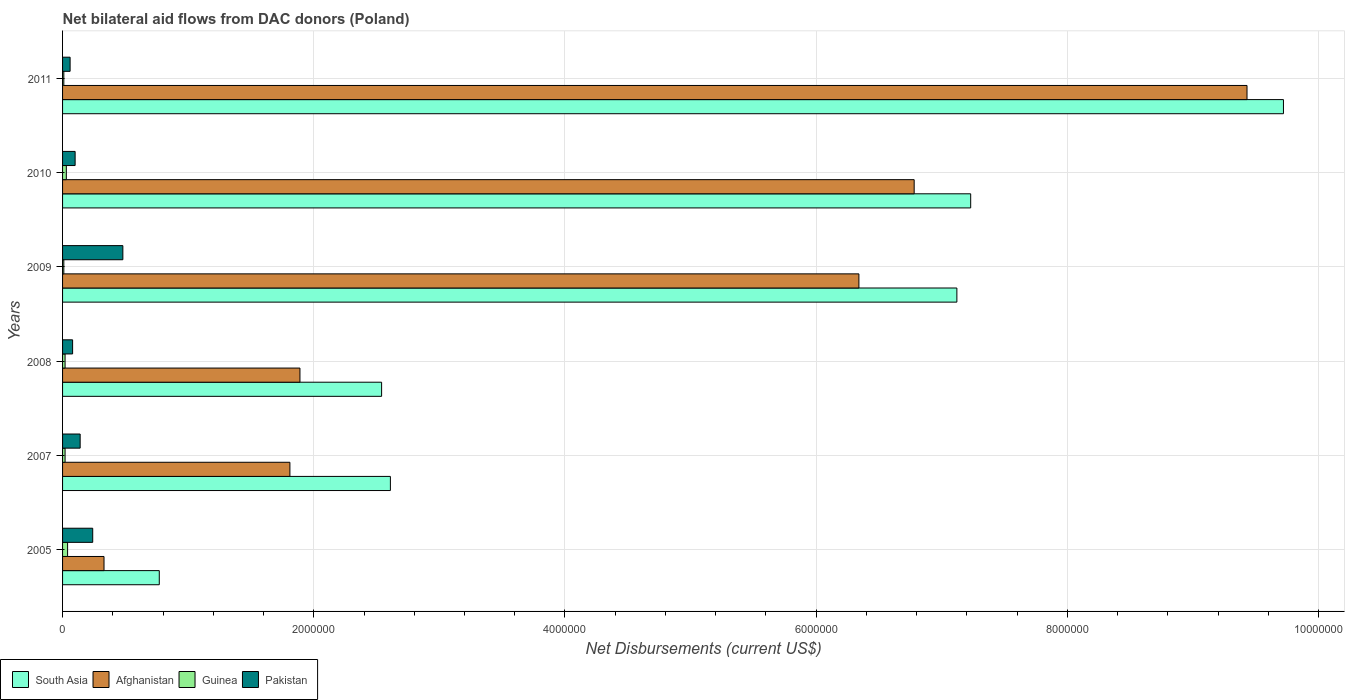How many groups of bars are there?
Provide a succinct answer. 6. Are the number of bars per tick equal to the number of legend labels?
Give a very brief answer. Yes. How many bars are there on the 2nd tick from the top?
Your response must be concise. 4. How many bars are there on the 5th tick from the bottom?
Your answer should be compact. 4. In how many cases, is the number of bars for a given year not equal to the number of legend labels?
Offer a terse response. 0. What is the net bilateral aid flows in South Asia in 2005?
Give a very brief answer. 7.70e+05. Across all years, what is the maximum net bilateral aid flows in South Asia?
Offer a very short reply. 9.72e+06. Across all years, what is the minimum net bilateral aid flows in Pakistan?
Offer a very short reply. 6.00e+04. In which year was the net bilateral aid flows in South Asia minimum?
Offer a very short reply. 2005. What is the difference between the net bilateral aid flows in South Asia in 2009 and that in 2011?
Your answer should be very brief. -2.60e+06. What is the difference between the net bilateral aid flows in South Asia in 2009 and the net bilateral aid flows in Guinea in 2011?
Make the answer very short. 7.11e+06. What is the average net bilateral aid flows in Pakistan per year?
Provide a short and direct response. 1.83e+05. In the year 2010, what is the difference between the net bilateral aid flows in South Asia and net bilateral aid flows in Afghanistan?
Offer a terse response. 4.50e+05. What is the difference between the highest and the second highest net bilateral aid flows in South Asia?
Your answer should be compact. 2.49e+06. What is the difference between the highest and the lowest net bilateral aid flows in Pakistan?
Your response must be concise. 4.20e+05. Is the sum of the net bilateral aid flows in Afghanistan in 2005 and 2009 greater than the maximum net bilateral aid flows in Guinea across all years?
Offer a terse response. Yes. Is it the case that in every year, the sum of the net bilateral aid flows in Afghanistan and net bilateral aid flows in Pakistan is greater than the sum of net bilateral aid flows in Guinea and net bilateral aid flows in South Asia?
Your answer should be compact. No. What does the 2nd bar from the top in 2009 represents?
Make the answer very short. Guinea. Does the graph contain grids?
Ensure brevity in your answer.  Yes. Where does the legend appear in the graph?
Make the answer very short. Bottom left. What is the title of the graph?
Offer a terse response. Net bilateral aid flows from DAC donors (Poland). Does "Belize" appear as one of the legend labels in the graph?
Ensure brevity in your answer.  No. What is the label or title of the X-axis?
Your response must be concise. Net Disbursements (current US$). What is the label or title of the Y-axis?
Provide a short and direct response. Years. What is the Net Disbursements (current US$) of South Asia in 2005?
Keep it short and to the point. 7.70e+05. What is the Net Disbursements (current US$) of South Asia in 2007?
Your response must be concise. 2.61e+06. What is the Net Disbursements (current US$) in Afghanistan in 2007?
Keep it short and to the point. 1.81e+06. What is the Net Disbursements (current US$) in Guinea in 2007?
Provide a short and direct response. 2.00e+04. What is the Net Disbursements (current US$) in South Asia in 2008?
Provide a short and direct response. 2.54e+06. What is the Net Disbursements (current US$) in Afghanistan in 2008?
Keep it short and to the point. 1.89e+06. What is the Net Disbursements (current US$) of Guinea in 2008?
Provide a short and direct response. 2.00e+04. What is the Net Disbursements (current US$) in Pakistan in 2008?
Provide a short and direct response. 8.00e+04. What is the Net Disbursements (current US$) of South Asia in 2009?
Keep it short and to the point. 7.12e+06. What is the Net Disbursements (current US$) of Afghanistan in 2009?
Offer a terse response. 6.34e+06. What is the Net Disbursements (current US$) in South Asia in 2010?
Ensure brevity in your answer.  7.23e+06. What is the Net Disbursements (current US$) in Afghanistan in 2010?
Your answer should be very brief. 6.78e+06. What is the Net Disbursements (current US$) in Guinea in 2010?
Offer a very short reply. 3.00e+04. What is the Net Disbursements (current US$) in Pakistan in 2010?
Provide a short and direct response. 1.00e+05. What is the Net Disbursements (current US$) of South Asia in 2011?
Your answer should be very brief. 9.72e+06. What is the Net Disbursements (current US$) in Afghanistan in 2011?
Provide a succinct answer. 9.43e+06. What is the Net Disbursements (current US$) in Guinea in 2011?
Give a very brief answer. 10000. What is the Net Disbursements (current US$) of Pakistan in 2011?
Make the answer very short. 6.00e+04. Across all years, what is the maximum Net Disbursements (current US$) of South Asia?
Provide a short and direct response. 9.72e+06. Across all years, what is the maximum Net Disbursements (current US$) of Afghanistan?
Keep it short and to the point. 9.43e+06. Across all years, what is the maximum Net Disbursements (current US$) in Guinea?
Offer a terse response. 4.00e+04. Across all years, what is the minimum Net Disbursements (current US$) of South Asia?
Offer a terse response. 7.70e+05. Across all years, what is the minimum Net Disbursements (current US$) of Guinea?
Your response must be concise. 10000. Across all years, what is the minimum Net Disbursements (current US$) of Pakistan?
Provide a succinct answer. 6.00e+04. What is the total Net Disbursements (current US$) of South Asia in the graph?
Offer a terse response. 3.00e+07. What is the total Net Disbursements (current US$) in Afghanistan in the graph?
Offer a terse response. 2.66e+07. What is the total Net Disbursements (current US$) of Pakistan in the graph?
Offer a terse response. 1.10e+06. What is the difference between the Net Disbursements (current US$) of South Asia in 2005 and that in 2007?
Provide a short and direct response. -1.84e+06. What is the difference between the Net Disbursements (current US$) of Afghanistan in 2005 and that in 2007?
Your answer should be compact. -1.48e+06. What is the difference between the Net Disbursements (current US$) of Guinea in 2005 and that in 2007?
Offer a very short reply. 2.00e+04. What is the difference between the Net Disbursements (current US$) of Pakistan in 2005 and that in 2007?
Give a very brief answer. 1.00e+05. What is the difference between the Net Disbursements (current US$) of South Asia in 2005 and that in 2008?
Provide a short and direct response. -1.77e+06. What is the difference between the Net Disbursements (current US$) in Afghanistan in 2005 and that in 2008?
Ensure brevity in your answer.  -1.56e+06. What is the difference between the Net Disbursements (current US$) in South Asia in 2005 and that in 2009?
Your answer should be very brief. -6.35e+06. What is the difference between the Net Disbursements (current US$) of Afghanistan in 2005 and that in 2009?
Give a very brief answer. -6.01e+06. What is the difference between the Net Disbursements (current US$) in Pakistan in 2005 and that in 2009?
Your answer should be compact. -2.40e+05. What is the difference between the Net Disbursements (current US$) in South Asia in 2005 and that in 2010?
Make the answer very short. -6.46e+06. What is the difference between the Net Disbursements (current US$) of Afghanistan in 2005 and that in 2010?
Offer a terse response. -6.45e+06. What is the difference between the Net Disbursements (current US$) in Guinea in 2005 and that in 2010?
Your answer should be compact. 10000. What is the difference between the Net Disbursements (current US$) of South Asia in 2005 and that in 2011?
Your answer should be very brief. -8.95e+06. What is the difference between the Net Disbursements (current US$) in Afghanistan in 2005 and that in 2011?
Give a very brief answer. -9.10e+06. What is the difference between the Net Disbursements (current US$) of Guinea in 2005 and that in 2011?
Make the answer very short. 3.00e+04. What is the difference between the Net Disbursements (current US$) in Pakistan in 2005 and that in 2011?
Keep it short and to the point. 1.80e+05. What is the difference between the Net Disbursements (current US$) of South Asia in 2007 and that in 2008?
Provide a succinct answer. 7.00e+04. What is the difference between the Net Disbursements (current US$) of Pakistan in 2007 and that in 2008?
Offer a very short reply. 6.00e+04. What is the difference between the Net Disbursements (current US$) of South Asia in 2007 and that in 2009?
Provide a succinct answer. -4.51e+06. What is the difference between the Net Disbursements (current US$) in Afghanistan in 2007 and that in 2009?
Your answer should be very brief. -4.53e+06. What is the difference between the Net Disbursements (current US$) of Guinea in 2007 and that in 2009?
Your answer should be very brief. 10000. What is the difference between the Net Disbursements (current US$) of South Asia in 2007 and that in 2010?
Provide a succinct answer. -4.62e+06. What is the difference between the Net Disbursements (current US$) of Afghanistan in 2007 and that in 2010?
Make the answer very short. -4.97e+06. What is the difference between the Net Disbursements (current US$) of Pakistan in 2007 and that in 2010?
Ensure brevity in your answer.  4.00e+04. What is the difference between the Net Disbursements (current US$) of South Asia in 2007 and that in 2011?
Ensure brevity in your answer.  -7.11e+06. What is the difference between the Net Disbursements (current US$) in Afghanistan in 2007 and that in 2011?
Keep it short and to the point. -7.62e+06. What is the difference between the Net Disbursements (current US$) of Guinea in 2007 and that in 2011?
Provide a succinct answer. 10000. What is the difference between the Net Disbursements (current US$) in Pakistan in 2007 and that in 2011?
Your answer should be compact. 8.00e+04. What is the difference between the Net Disbursements (current US$) of South Asia in 2008 and that in 2009?
Give a very brief answer. -4.58e+06. What is the difference between the Net Disbursements (current US$) in Afghanistan in 2008 and that in 2009?
Provide a succinct answer. -4.45e+06. What is the difference between the Net Disbursements (current US$) of Guinea in 2008 and that in 2009?
Provide a short and direct response. 10000. What is the difference between the Net Disbursements (current US$) of Pakistan in 2008 and that in 2009?
Your answer should be compact. -4.00e+05. What is the difference between the Net Disbursements (current US$) in South Asia in 2008 and that in 2010?
Ensure brevity in your answer.  -4.69e+06. What is the difference between the Net Disbursements (current US$) of Afghanistan in 2008 and that in 2010?
Make the answer very short. -4.89e+06. What is the difference between the Net Disbursements (current US$) in Guinea in 2008 and that in 2010?
Give a very brief answer. -10000. What is the difference between the Net Disbursements (current US$) of Pakistan in 2008 and that in 2010?
Offer a very short reply. -2.00e+04. What is the difference between the Net Disbursements (current US$) in South Asia in 2008 and that in 2011?
Make the answer very short. -7.18e+06. What is the difference between the Net Disbursements (current US$) of Afghanistan in 2008 and that in 2011?
Offer a terse response. -7.54e+06. What is the difference between the Net Disbursements (current US$) in Guinea in 2008 and that in 2011?
Your response must be concise. 10000. What is the difference between the Net Disbursements (current US$) of South Asia in 2009 and that in 2010?
Your response must be concise. -1.10e+05. What is the difference between the Net Disbursements (current US$) of Afghanistan in 2009 and that in 2010?
Ensure brevity in your answer.  -4.40e+05. What is the difference between the Net Disbursements (current US$) in Guinea in 2009 and that in 2010?
Provide a succinct answer. -2.00e+04. What is the difference between the Net Disbursements (current US$) in South Asia in 2009 and that in 2011?
Offer a terse response. -2.60e+06. What is the difference between the Net Disbursements (current US$) in Afghanistan in 2009 and that in 2011?
Offer a terse response. -3.09e+06. What is the difference between the Net Disbursements (current US$) in Pakistan in 2009 and that in 2011?
Your answer should be compact. 4.20e+05. What is the difference between the Net Disbursements (current US$) in South Asia in 2010 and that in 2011?
Provide a succinct answer. -2.49e+06. What is the difference between the Net Disbursements (current US$) in Afghanistan in 2010 and that in 2011?
Make the answer very short. -2.65e+06. What is the difference between the Net Disbursements (current US$) in Guinea in 2010 and that in 2011?
Give a very brief answer. 2.00e+04. What is the difference between the Net Disbursements (current US$) in South Asia in 2005 and the Net Disbursements (current US$) in Afghanistan in 2007?
Keep it short and to the point. -1.04e+06. What is the difference between the Net Disbursements (current US$) of South Asia in 2005 and the Net Disbursements (current US$) of Guinea in 2007?
Offer a terse response. 7.50e+05. What is the difference between the Net Disbursements (current US$) in South Asia in 2005 and the Net Disbursements (current US$) in Pakistan in 2007?
Your response must be concise. 6.30e+05. What is the difference between the Net Disbursements (current US$) in Guinea in 2005 and the Net Disbursements (current US$) in Pakistan in 2007?
Offer a terse response. -1.00e+05. What is the difference between the Net Disbursements (current US$) in South Asia in 2005 and the Net Disbursements (current US$) in Afghanistan in 2008?
Your answer should be very brief. -1.12e+06. What is the difference between the Net Disbursements (current US$) of South Asia in 2005 and the Net Disbursements (current US$) of Guinea in 2008?
Your answer should be compact. 7.50e+05. What is the difference between the Net Disbursements (current US$) in South Asia in 2005 and the Net Disbursements (current US$) in Pakistan in 2008?
Ensure brevity in your answer.  6.90e+05. What is the difference between the Net Disbursements (current US$) in Afghanistan in 2005 and the Net Disbursements (current US$) in Pakistan in 2008?
Your answer should be compact. 2.50e+05. What is the difference between the Net Disbursements (current US$) of Guinea in 2005 and the Net Disbursements (current US$) of Pakistan in 2008?
Keep it short and to the point. -4.00e+04. What is the difference between the Net Disbursements (current US$) of South Asia in 2005 and the Net Disbursements (current US$) of Afghanistan in 2009?
Your response must be concise. -5.57e+06. What is the difference between the Net Disbursements (current US$) of South Asia in 2005 and the Net Disbursements (current US$) of Guinea in 2009?
Keep it short and to the point. 7.60e+05. What is the difference between the Net Disbursements (current US$) in South Asia in 2005 and the Net Disbursements (current US$) in Pakistan in 2009?
Give a very brief answer. 2.90e+05. What is the difference between the Net Disbursements (current US$) in Afghanistan in 2005 and the Net Disbursements (current US$) in Guinea in 2009?
Provide a short and direct response. 3.20e+05. What is the difference between the Net Disbursements (current US$) of Afghanistan in 2005 and the Net Disbursements (current US$) of Pakistan in 2009?
Provide a short and direct response. -1.50e+05. What is the difference between the Net Disbursements (current US$) of Guinea in 2005 and the Net Disbursements (current US$) of Pakistan in 2009?
Ensure brevity in your answer.  -4.40e+05. What is the difference between the Net Disbursements (current US$) of South Asia in 2005 and the Net Disbursements (current US$) of Afghanistan in 2010?
Your response must be concise. -6.01e+06. What is the difference between the Net Disbursements (current US$) of South Asia in 2005 and the Net Disbursements (current US$) of Guinea in 2010?
Offer a very short reply. 7.40e+05. What is the difference between the Net Disbursements (current US$) in South Asia in 2005 and the Net Disbursements (current US$) in Pakistan in 2010?
Provide a succinct answer. 6.70e+05. What is the difference between the Net Disbursements (current US$) of Afghanistan in 2005 and the Net Disbursements (current US$) of Guinea in 2010?
Provide a succinct answer. 3.00e+05. What is the difference between the Net Disbursements (current US$) in Afghanistan in 2005 and the Net Disbursements (current US$) in Pakistan in 2010?
Provide a short and direct response. 2.30e+05. What is the difference between the Net Disbursements (current US$) of Guinea in 2005 and the Net Disbursements (current US$) of Pakistan in 2010?
Provide a short and direct response. -6.00e+04. What is the difference between the Net Disbursements (current US$) in South Asia in 2005 and the Net Disbursements (current US$) in Afghanistan in 2011?
Offer a very short reply. -8.66e+06. What is the difference between the Net Disbursements (current US$) in South Asia in 2005 and the Net Disbursements (current US$) in Guinea in 2011?
Keep it short and to the point. 7.60e+05. What is the difference between the Net Disbursements (current US$) in South Asia in 2005 and the Net Disbursements (current US$) in Pakistan in 2011?
Make the answer very short. 7.10e+05. What is the difference between the Net Disbursements (current US$) in Afghanistan in 2005 and the Net Disbursements (current US$) in Pakistan in 2011?
Your answer should be compact. 2.70e+05. What is the difference between the Net Disbursements (current US$) of South Asia in 2007 and the Net Disbursements (current US$) of Afghanistan in 2008?
Ensure brevity in your answer.  7.20e+05. What is the difference between the Net Disbursements (current US$) in South Asia in 2007 and the Net Disbursements (current US$) in Guinea in 2008?
Your answer should be compact. 2.59e+06. What is the difference between the Net Disbursements (current US$) of South Asia in 2007 and the Net Disbursements (current US$) of Pakistan in 2008?
Give a very brief answer. 2.53e+06. What is the difference between the Net Disbursements (current US$) of Afghanistan in 2007 and the Net Disbursements (current US$) of Guinea in 2008?
Your response must be concise. 1.79e+06. What is the difference between the Net Disbursements (current US$) in Afghanistan in 2007 and the Net Disbursements (current US$) in Pakistan in 2008?
Make the answer very short. 1.73e+06. What is the difference between the Net Disbursements (current US$) of South Asia in 2007 and the Net Disbursements (current US$) of Afghanistan in 2009?
Keep it short and to the point. -3.73e+06. What is the difference between the Net Disbursements (current US$) of South Asia in 2007 and the Net Disbursements (current US$) of Guinea in 2009?
Offer a very short reply. 2.60e+06. What is the difference between the Net Disbursements (current US$) in South Asia in 2007 and the Net Disbursements (current US$) in Pakistan in 2009?
Give a very brief answer. 2.13e+06. What is the difference between the Net Disbursements (current US$) in Afghanistan in 2007 and the Net Disbursements (current US$) in Guinea in 2009?
Your response must be concise. 1.80e+06. What is the difference between the Net Disbursements (current US$) in Afghanistan in 2007 and the Net Disbursements (current US$) in Pakistan in 2009?
Provide a short and direct response. 1.33e+06. What is the difference between the Net Disbursements (current US$) of Guinea in 2007 and the Net Disbursements (current US$) of Pakistan in 2009?
Offer a terse response. -4.60e+05. What is the difference between the Net Disbursements (current US$) in South Asia in 2007 and the Net Disbursements (current US$) in Afghanistan in 2010?
Your answer should be compact. -4.17e+06. What is the difference between the Net Disbursements (current US$) of South Asia in 2007 and the Net Disbursements (current US$) of Guinea in 2010?
Make the answer very short. 2.58e+06. What is the difference between the Net Disbursements (current US$) in South Asia in 2007 and the Net Disbursements (current US$) in Pakistan in 2010?
Give a very brief answer. 2.51e+06. What is the difference between the Net Disbursements (current US$) of Afghanistan in 2007 and the Net Disbursements (current US$) of Guinea in 2010?
Offer a very short reply. 1.78e+06. What is the difference between the Net Disbursements (current US$) in Afghanistan in 2007 and the Net Disbursements (current US$) in Pakistan in 2010?
Give a very brief answer. 1.71e+06. What is the difference between the Net Disbursements (current US$) in South Asia in 2007 and the Net Disbursements (current US$) in Afghanistan in 2011?
Your response must be concise. -6.82e+06. What is the difference between the Net Disbursements (current US$) in South Asia in 2007 and the Net Disbursements (current US$) in Guinea in 2011?
Ensure brevity in your answer.  2.60e+06. What is the difference between the Net Disbursements (current US$) in South Asia in 2007 and the Net Disbursements (current US$) in Pakistan in 2011?
Your answer should be compact. 2.55e+06. What is the difference between the Net Disbursements (current US$) in Afghanistan in 2007 and the Net Disbursements (current US$) in Guinea in 2011?
Offer a very short reply. 1.80e+06. What is the difference between the Net Disbursements (current US$) of Afghanistan in 2007 and the Net Disbursements (current US$) of Pakistan in 2011?
Offer a very short reply. 1.75e+06. What is the difference between the Net Disbursements (current US$) in Guinea in 2007 and the Net Disbursements (current US$) in Pakistan in 2011?
Offer a terse response. -4.00e+04. What is the difference between the Net Disbursements (current US$) of South Asia in 2008 and the Net Disbursements (current US$) of Afghanistan in 2009?
Make the answer very short. -3.80e+06. What is the difference between the Net Disbursements (current US$) in South Asia in 2008 and the Net Disbursements (current US$) in Guinea in 2009?
Provide a short and direct response. 2.53e+06. What is the difference between the Net Disbursements (current US$) of South Asia in 2008 and the Net Disbursements (current US$) of Pakistan in 2009?
Keep it short and to the point. 2.06e+06. What is the difference between the Net Disbursements (current US$) of Afghanistan in 2008 and the Net Disbursements (current US$) of Guinea in 2009?
Offer a terse response. 1.88e+06. What is the difference between the Net Disbursements (current US$) of Afghanistan in 2008 and the Net Disbursements (current US$) of Pakistan in 2009?
Your answer should be compact. 1.41e+06. What is the difference between the Net Disbursements (current US$) in Guinea in 2008 and the Net Disbursements (current US$) in Pakistan in 2009?
Your response must be concise. -4.60e+05. What is the difference between the Net Disbursements (current US$) in South Asia in 2008 and the Net Disbursements (current US$) in Afghanistan in 2010?
Offer a very short reply. -4.24e+06. What is the difference between the Net Disbursements (current US$) in South Asia in 2008 and the Net Disbursements (current US$) in Guinea in 2010?
Provide a short and direct response. 2.51e+06. What is the difference between the Net Disbursements (current US$) in South Asia in 2008 and the Net Disbursements (current US$) in Pakistan in 2010?
Keep it short and to the point. 2.44e+06. What is the difference between the Net Disbursements (current US$) of Afghanistan in 2008 and the Net Disbursements (current US$) of Guinea in 2010?
Your answer should be very brief. 1.86e+06. What is the difference between the Net Disbursements (current US$) of Afghanistan in 2008 and the Net Disbursements (current US$) of Pakistan in 2010?
Your response must be concise. 1.79e+06. What is the difference between the Net Disbursements (current US$) of South Asia in 2008 and the Net Disbursements (current US$) of Afghanistan in 2011?
Keep it short and to the point. -6.89e+06. What is the difference between the Net Disbursements (current US$) in South Asia in 2008 and the Net Disbursements (current US$) in Guinea in 2011?
Your answer should be very brief. 2.53e+06. What is the difference between the Net Disbursements (current US$) in South Asia in 2008 and the Net Disbursements (current US$) in Pakistan in 2011?
Keep it short and to the point. 2.48e+06. What is the difference between the Net Disbursements (current US$) of Afghanistan in 2008 and the Net Disbursements (current US$) of Guinea in 2011?
Your response must be concise. 1.88e+06. What is the difference between the Net Disbursements (current US$) of Afghanistan in 2008 and the Net Disbursements (current US$) of Pakistan in 2011?
Ensure brevity in your answer.  1.83e+06. What is the difference between the Net Disbursements (current US$) in South Asia in 2009 and the Net Disbursements (current US$) in Afghanistan in 2010?
Make the answer very short. 3.40e+05. What is the difference between the Net Disbursements (current US$) in South Asia in 2009 and the Net Disbursements (current US$) in Guinea in 2010?
Offer a terse response. 7.09e+06. What is the difference between the Net Disbursements (current US$) in South Asia in 2009 and the Net Disbursements (current US$) in Pakistan in 2010?
Ensure brevity in your answer.  7.02e+06. What is the difference between the Net Disbursements (current US$) in Afghanistan in 2009 and the Net Disbursements (current US$) in Guinea in 2010?
Make the answer very short. 6.31e+06. What is the difference between the Net Disbursements (current US$) of Afghanistan in 2009 and the Net Disbursements (current US$) of Pakistan in 2010?
Your response must be concise. 6.24e+06. What is the difference between the Net Disbursements (current US$) of South Asia in 2009 and the Net Disbursements (current US$) of Afghanistan in 2011?
Provide a succinct answer. -2.31e+06. What is the difference between the Net Disbursements (current US$) in South Asia in 2009 and the Net Disbursements (current US$) in Guinea in 2011?
Provide a succinct answer. 7.11e+06. What is the difference between the Net Disbursements (current US$) of South Asia in 2009 and the Net Disbursements (current US$) of Pakistan in 2011?
Your answer should be compact. 7.06e+06. What is the difference between the Net Disbursements (current US$) of Afghanistan in 2009 and the Net Disbursements (current US$) of Guinea in 2011?
Your answer should be very brief. 6.33e+06. What is the difference between the Net Disbursements (current US$) in Afghanistan in 2009 and the Net Disbursements (current US$) in Pakistan in 2011?
Keep it short and to the point. 6.28e+06. What is the difference between the Net Disbursements (current US$) of Guinea in 2009 and the Net Disbursements (current US$) of Pakistan in 2011?
Give a very brief answer. -5.00e+04. What is the difference between the Net Disbursements (current US$) in South Asia in 2010 and the Net Disbursements (current US$) in Afghanistan in 2011?
Your answer should be very brief. -2.20e+06. What is the difference between the Net Disbursements (current US$) in South Asia in 2010 and the Net Disbursements (current US$) in Guinea in 2011?
Ensure brevity in your answer.  7.22e+06. What is the difference between the Net Disbursements (current US$) in South Asia in 2010 and the Net Disbursements (current US$) in Pakistan in 2011?
Make the answer very short. 7.17e+06. What is the difference between the Net Disbursements (current US$) in Afghanistan in 2010 and the Net Disbursements (current US$) in Guinea in 2011?
Provide a succinct answer. 6.77e+06. What is the difference between the Net Disbursements (current US$) of Afghanistan in 2010 and the Net Disbursements (current US$) of Pakistan in 2011?
Provide a short and direct response. 6.72e+06. What is the difference between the Net Disbursements (current US$) in Guinea in 2010 and the Net Disbursements (current US$) in Pakistan in 2011?
Ensure brevity in your answer.  -3.00e+04. What is the average Net Disbursements (current US$) in South Asia per year?
Your answer should be compact. 5.00e+06. What is the average Net Disbursements (current US$) in Afghanistan per year?
Your answer should be compact. 4.43e+06. What is the average Net Disbursements (current US$) of Guinea per year?
Offer a very short reply. 2.17e+04. What is the average Net Disbursements (current US$) in Pakistan per year?
Offer a terse response. 1.83e+05. In the year 2005, what is the difference between the Net Disbursements (current US$) in South Asia and Net Disbursements (current US$) in Afghanistan?
Give a very brief answer. 4.40e+05. In the year 2005, what is the difference between the Net Disbursements (current US$) of South Asia and Net Disbursements (current US$) of Guinea?
Your answer should be very brief. 7.30e+05. In the year 2005, what is the difference between the Net Disbursements (current US$) of South Asia and Net Disbursements (current US$) of Pakistan?
Keep it short and to the point. 5.30e+05. In the year 2005, what is the difference between the Net Disbursements (current US$) of Guinea and Net Disbursements (current US$) of Pakistan?
Provide a succinct answer. -2.00e+05. In the year 2007, what is the difference between the Net Disbursements (current US$) in South Asia and Net Disbursements (current US$) in Afghanistan?
Make the answer very short. 8.00e+05. In the year 2007, what is the difference between the Net Disbursements (current US$) of South Asia and Net Disbursements (current US$) of Guinea?
Offer a very short reply. 2.59e+06. In the year 2007, what is the difference between the Net Disbursements (current US$) in South Asia and Net Disbursements (current US$) in Pakistan?
Offer a very short reply. 2.47e+06. In the year 2007, what is the difference between the Net Disbursements (current US$) of Afghanistan and Net Disbursements (current US$) of Guinea?
Offer a terse response. 1.79e+06. In the year 2007, what is the difference between the Net Disbursements (current US$) in Afghanistan and Net Disbursements (current US$) in Pakistan?
Make the answer very short. 1.67e+06. In the year 2007, what is the difference between the Net Disbursements (current US$) of Guinea and Net Disbursements (current US$) of Pakistan?
Keep it short and to the point. -1.20e+05. In the year 2008, what is the difference between the Net Disbursements (current US$) in South Asia and Net Disbursements (current US$) in Afghanistan?
Offer a very short reply. 6.50e+05. In the year 2008, what is the difference between the Net Disbursements (current US$) of South Asia and Net Disbursements (current US$) of Guinea?
Provide a short and direct response. 2.52e+06. In the year 2008, what is the difference between the Net Disbursements (current US$) of South Asia and Net Disbursements (current US$) of Pakistan?
Ensure brevity in your answer.  2.46e+06. In the year 2008, what is the difference between the Net Disbursements (current US$) in Afghanistan and Net Disbursements (current US$) in Guinea?
Ensure brevity in your answer.  1.87e+06. In the year 2008, what is the difference between the Net Disbursements (current US$) of Afghanistan and Net Disbursements (current US$) of Pakistan?
Keep it short and to the point. 1.81e+06. In the year 2009, what is the difference between the Net Disbursements (current US$) in South Asia and Net Disbursements (current US$) in Afghanistan?
Your answer should be very brief. 7.80e+05. In the year 2009, what is the difference between the Net Disbursements (current US$) in South Asia and Net Disbursements (current US$) in Guinea?
Offer a terse response. 7.11e+06. In the year 2009, what is the difference between the Net Disbursements (current US$) of South Asia and Net Disbursements (current US$) of Pakistan?
Your answer should be very brief. 6.64e+06. In the year 2009, what is the difference between the Net Disbursements (current US$) of Afghanistan and Net Disbursements (current US$) of Guinea?
Your response must be concise. 6.33e+06. In the year 2009, what is the difference between the Net Disbursements (current US$) in Afghanistan and Net Disbursements (current US$) in Pakistan?
Give a very brief answer. 5.86e+06. In the year 2009, what is the difference between the Net Disbursements (current US$) in Guinea and Net Disbursements (current US$) in Pakistan?
Ensure brevity in your answer.  -4.70e+05. In the year 2010, what is the difference between the Net Disbursements (current US$) of South Asia and Net Disbursements (current US$) of Guinea?
Keep it short and to the point. 7.20e+06. In the year 2010, what is the difference between the Net Disbursements (current US$) of South Asia and Net Disbursements (current US$) of Pakistan?
Keep it short and to the point. 7.13e+06. In the year 2010, what is the difference between the Net Disbursements (current US$) in Afghanistan and Net Disbursements (current US$) in Guinea?
Your response must be concise. 6.75e+06. In the year 2010, what is the difference between the Net Disbursements (current US$) of Afghanistan and Net Disbursements (current US$) of Pakistan?
Make the answer very short. 6.68e+06. In the year 2011, what is the difference between the Net Disbursements (current US$) of South Asia and Net Disbursements (current US$) of Guinea?
Your answer should be very brief. 9.71e+06. In the year 2011, what is the difference between the Net Disbursements (current US$) in South Asia and Net Disbursements (current US$) in Pakistan?
Give a very brief answer. 9.66e+06. In the year 2011, what is the difference between the Net Disbursements (current US$) of Afghanistan and Net Disbursements (current US$) of Guinea?
Give a very brief answer. 9.42e+06. In the year 2011, what is the difference between the Net Disbursements (current US$) in Afghanistan and Net Disbursements (current US$) in Pakistan?
Offer a terse response. 9.37e+06. In the year 2011, what is the difference between the Net Disbursements (current US$) of Guinea and Net Disbursements (current US$) of Pakistan?
Make the answer very short. -5.00e+04. What is the ratio of the Net Disbursements (current US$) in South Asia in 2005 to that in 2007?
Keep it short and to the point. 0.29. What is the ratio of the Net Disbursements (current US$) in Afghanistan in 2005 to that in 2007?
Keep it short and to the point. 0.18. What is the ratio of the Net Disbursements (current US$) of Guinea in 2005 to that in 2007?
Offer a terse response. 2. What is the ratio of the Net Disbursements (current US$) of Pakistan in 2005 to that in 2007?
Give a very brief answer. 1.71. What is the ratio of the Net Disbursements (current US$) in South Asia in 2005 to that in 2008?
Give a very brief answer. 0.3. What is the ratio of the Net Disbursements (current US$) of Afghanistan in 2005 to that in 2008?
Your answer should be compact. 0.17. What is the ratio of the Net Disbursements (current US$) in Guinea in 2005 to that in 2008?
Offer a terse response. 2. What is the ratio of the Net Disbursements (current US$) of South Asia in 2005 to that in 2009?
Your response must be concise. 0.11. What is the ratio of the Net Disbursements (current US$) in Afghanistan in 2005 to that in 2009?
Your response must be concise. 0.05. What is the ratio of the Net Disbursements (current US$) in Guinea in 2005 to that in 2009?
Offer a terse response. 4. What is the ratio of the Net Disbursements (current US$) in South Asia in 2005 to that in 2010?
Give a very brief answer. 0.11. What is the ratio of the Net Disbursements (current US$) in Afghanistan in 2005 to that in 2010?
Make the answer very short. 0.05. What is the ratio of the Net Disbursements (current US$) of Guinea in 2005 to that in 2010?
Your response must be concise. 1.33. What is the ratio of the Net Disbursements (current US$) in Pakistan in 2005 to that in 2010?
Your answer should be compact. 2.4. What is the ratio of the Net Disbursements (current US$) in South Asia in 2005 to that in 2011?
Make the answer very short. 0.08. What is the ratio of the Net Disbursements (current US$) of Afghanistan in 2005 to that in 2011?
Your answer should be compact. 0.04. What is the ratio of the Net Disbursements (current US$) of Guinea in 2005 to that in 2011?
Offer a very short reply. 4. What is the ratio of the Net Disbursements (current US$) of Pakistan in 2005 to that in 2011?
Give a very brief answer. 4. What is the ratio of the Net Disbursements (current US$) in South Asia in 2007 to that in 2008?
Ensure brevity in your answer.  1.03. What is the ratio of the Net Disbursements (current US$) in Afghanistan in 2007 to that in 2008?
Keep it short and to the point. 0.96. What is the ratio of the Net Disbursements (current US$) in Guinea in 2007 to that in 2008?
Your answer should be very brief. 1. What is the ratio of the Net Disbursements (current US$) of South Asia in 2007 to that in 2009?
Offer a terse response. 0.37. What is the ratio of the Net Disbursements (current US$) in Afghanistan in 2007 to that in 2009?
Your answer should be compact. 0.29. What is the ratio of the Net Disbursements (current US$) of Guinea in 2007 to that in 2009?
Offer a terse response. 2. What is the ratio of the Net Disbursements (current US$) of Pakistan in 2007 to that in 2009?
Keep it short and to the point. 0.29. What is the ratio of the Net Disbursements (current US$) in South Asia in 2007 to that in 2010?
Your answer should be very brief. 0.36. What is the ratio of the Net Disbursements (current US$) in Afghanistan in 2007 to that in 2010?
Make the answer very short. 0.27. What is the ratio of the Net Disbursements (current US$) of South Asia in 2007 to that in 2011?
Provide a short and direct response. 0.27. What is the ratio of the Net Disbursements (current US$) in Afghanistan in 2007 to that in 2011?
Your answer should be very brief. 0.19. What is the ratio of the Net Disbursements (current US$) of Pakistan in 2007 to that in 2011?
Your response must be concise. 2.33. What is the ratio of the Net Disbursements (current US$) of South Asia in 2008 to that in 2009?
Your response must be concise. 0.36. What is the ratio of the Net Disbursements (current US$) of Afghanistan in 2008 to that in 2009?
Make the answer very short. 0.3. What is the ratio of the Net Disbursements (current US$) of Pakistan in 2008 to that in 2009?
Your answer should be compact. 0.17. What is the ratio of the Net Disbursements (current US$) of South Asia in 2008 to that in 2010?
Your answer should be compact. 0.35. What is the ratio of the Net Disbursements (current US$) in Afghanistan in 2008 to that in 2010?
Offer a very short reply. 0.28. What is the ratio of the Net Disbursements (current US$) of Guinea in 2008 to that in 2010?
Your answer should be compact. 0.67. What is the ratio of the Net Disbursements (current US$) of Pakistan in 2008 to that in 2010?
Offer a very short reply. 0.8. What is the ratio of the Net Disbursements (current US$) in South Asia in 2008 to that in 2011?
Ensure brevity in your answer.  0.26. What is the ratio of the Net Disbursements (current US$) of Afghanistan in 2008 to that in 2011?
Your answer should be very brief. 0.2. What is the ratio of the Net Disbursements (current US$) of Afghanistan in 2009 to that in 2010?
Make the answer very short. 0.94. What is the ratio of the Net Disbursements (current US$) in South Asia in 2009 to that in 2011?
Your answer should be compact. 0.73. What is the ratio of the Net Disbursements (current US$) in Afghanistan in 2009 to that in 2011?
Ensure brevity in your answer.  0.67. What is the ratio of the Net Disbursements (current US$) in Guinea in 2009 to that in 2011?
Give a very brief answer. 1. What is the ratio of the Net Disbursements (current US$) in Pakistan in 2009 to that in 2011?
Your response must be concise. 8. What is the ratio of the Net Disbursements (current US$) of South Asia in 2010 to that in 2011?
Give a very brief answer. 0.74. What is the ratio of the Net Disbursements (current US$) in Afghanistan in 2010 to that in 2011?
Your answer should be very brief. 0.72. What is the ratio of the Net Disbursements (current US$) of Guinea in 2010 to that in 2011?
Offer a terse response. 3. What is the difference between the highest and the second highest Net Disbursements (current US$) in South Asia?
Ensure brevity in your answer.  2.49e+06. What is the difference between the highest and the second highest Net Disbursements (current US$) of Afghanistan?
Keep it short and to the point. 2.65e+06. What is the difference between the highest and the second highest Net Disbursements (current US$) of Pakistan?
Make the answer very short. 2.40e+05. What is the difference between the highest and the lowest Net Disbursements (current US$) of South Asia?
Make the answer very short. 8.95e+06. What is the difference between the highest and the lowest Net Disbursements (current US$) of Afghanistan?
Provide a succinct answer. 9.10e+06. 